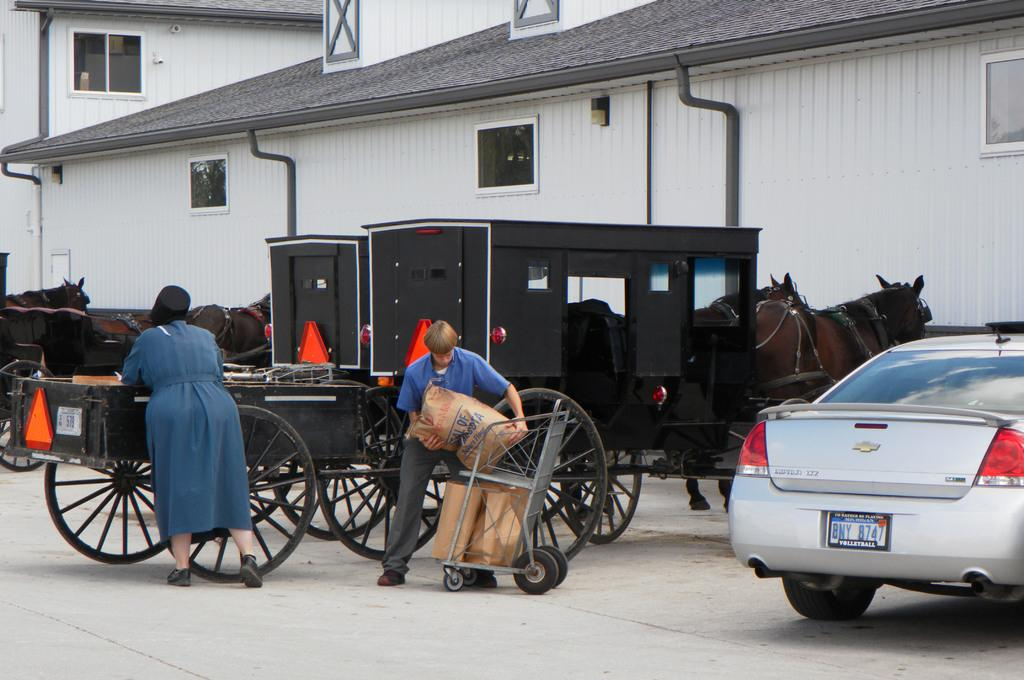How many people are present in the image? There are two people in the image. What vehicle is visible in the image? There is a car in the image. What objects are on the road in the image? There are carts on the road in the image. What type of structures can be seen in the background of the image? There are sheds in the background of the image. What is being transported on the trolley in the image? Carry bags are placed on a trolley in the image. What sense is being expressed by the people in the image? The image does not convey any sense or emotion; it simply shows two people, a car, carts, sheds, and carry bags on a trolley. 